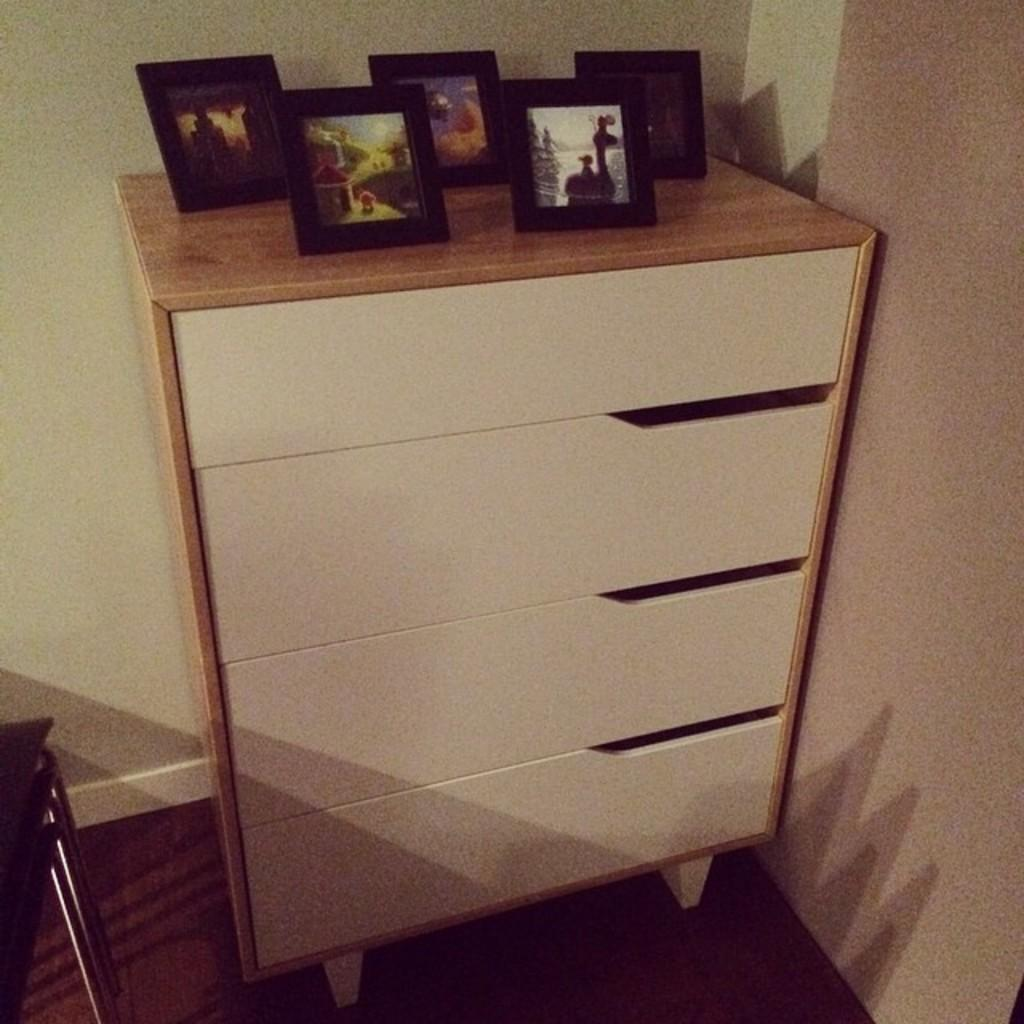What type of furniture is present in the image? There is a table in the image. Where is the table located in relation to other objects or structures? The table is in front of a wall. What items can be seen on the table? There are photographs on the table. What type of wound can be seen on the table in the image? There is no wound present on the table in the image; it only contains photographs. 